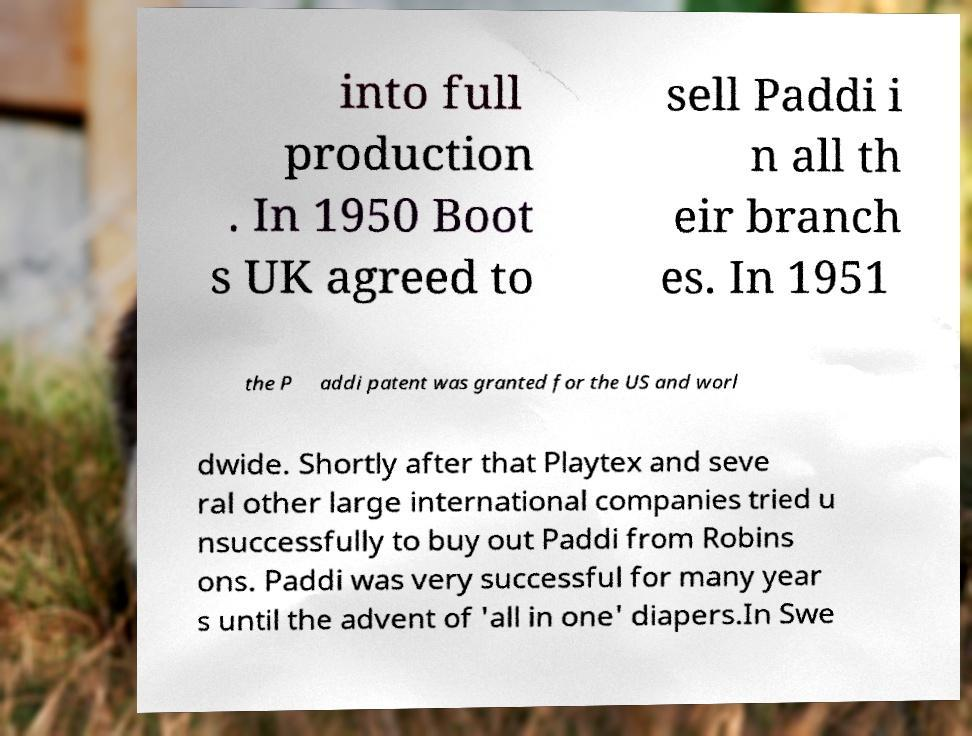For documentation purposes, I need the text within this image transcribed. Could you provide that? into full production . In 1950 Boot s UK agreed to sell Paddi i n all th eir branch es. In 1951 the P addi patent was granted for the US and worl dwide. Shortly after that Playtex and seve ral other large international companies tried u nsuccessfully to buy out Paddi from Robins ons. Paddi was very successful for many year s until the advent of 'all in one' diapers.In Swe 